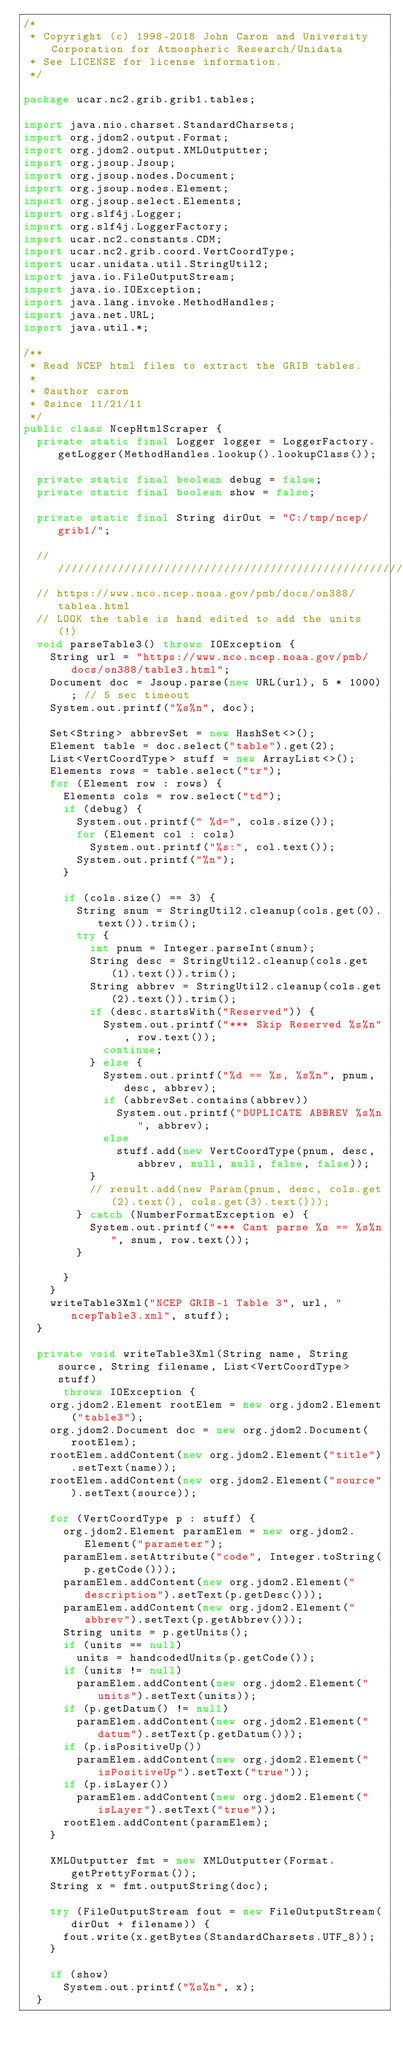<code> <loc_0><loc_0><loc_500><loc_500><_Java_>/*
 * Copyright (c) 1998-2018 John Caron and University Corporation for Atmospheric Research/Unidata
 * See LICENSE for license information.
 */

package ucar.nc2.grib.grib1.tables;

import java.nio.charset.StandardCharsets;
import org.jdom2.output.Format;
import org.jdom2.output.XMLOutputter;
import org.jsoup.Jsoup;
import org.jsoup.nodes.Document;
import org.jsoup.nodes.Element;
import org.jsoup.select.Elements;
import org.slf4j.Logger;
import org.slf4j.LoggerFactory;
import ucar.nc2.constants.CDM;
import ucar.nc2.grib.coord.VertCoordType;
import ucar.unidata.util.StringUtil2;
import java.io.FileOutputStream;
import java.io.IOException;
import java.lang.invoke.MethodHandles;
import java.net.URL;
import java.util.*;

/**
 * Read NCEP html files to extract the GRIB tables.
 *
 * @author caron
 * @since 11/21/11
 */
public class NcepHtmlScraper {
  private static final Logger logger = LoggerFactory.getLogger(MethodHandles.lookup().lookupClass());

  private static final boolean debug = false;
  private static final boolean show = false;

  private static final String dirOut = "C:/tmp/ncep/grib1/";

  //////////////////////////////////////////////////////////////////
  // https://www.nco.ncep.noaa.gov/pmb/docs/on388/tablea.html
  // LOOK the table is hand edited to add the units (!)
  void parseTable3() throws IOException {
    String url = "https://www.nco.ncep.noaa.gov/pmb/docs/on388/table3.html";
    Document doc = Jsoup.parse(new URL(url), 5 * 1000); // 5 sec timeout
    System.out.printf("%s%n", doc);

    Set<String> abbrevSet = new HashSet<>();
    Element table = doc.select("table").get(2);
    List<VertCoordType> stuff = new ArrayList<>();
    Elements rows = table.select("tr");
    for (Element row : rows) {
      Elements cols = row.select("td");
      if (debug) {
        System.out.printf(" %d=", cols.size());
        for (Element col : cols)
          System.out.printf("%s:", col.text());
        System.out.printf("%n");
      }

      if (cols.size() == 3) {
        String snum = StringUtil2.cleanup(cols.get(0).text()).trim();
        try {
          int pnum = Integer.parseInt(snum);
          String desc = StringUtil2.cleanup(cols.get(1).text()).trim();
          String abbrev = StringUtil2.cleanup(cols.get(2).text()).trim();
          if (desc.startsWith("Reserved")) {
            System.out.printf("*** Skip Reserved %s%n", row.text());
            continue;
          } else {
            System.out.printf("%d == %s, %s%n", pnum, desc, abbrev);
            if (abbrevSet.contains(abbrev))
              System.out.printf("DUPLICATE ABBREV %s%n", abbrev);
            else
              stuff.add(new VertCoordType(pnum, desc, abbrev, null, null, false, false));
          }
          // result.add(new Param(pnum, desc, cols.get(2).text(), cols.get(3).text()));
        } catch (NumberFormatException e) {
          System.out.printf("*** Cant parse %s == %s%n", snum, row.text());
        }

      }
    }
    writeTable3Xml("NCEP GRIB-1 Table 3", url, "ncepTable3.xml", stuff);
  }

  private void writeTable3Xml(String name, String source, String filename, List<VertCoordType> stuff)
      throws IOException {
    org.jdom2.Element rootElem = new org.jdom2.Element("table3");
    org.jdom2.Document doc = new org.jdom2.Document(rootElem);
    rootElem.addContent(new org.jdom2.Element("title").setText(name));
    rootElem.addContent(new org.jdom2.Element("source").setText(source));

    for (VertCoordType p : stuff) {
      org.jdom2.Element paramElem = new org.jdom2.Element("parameter");
      paramElem.setAttribute("code", Integer.toString(p.getCode()));
      paramElem.addContent(new org.jdom2.Element("description").setText(p.getDesc()));
      paramElem.addContent(new org.jdom2.Element("abbrev").setText(p.getAbbrev()));
      String units = p.getUnits();
      if (units == null)
        units = handcodedUnits(p.getCode());
      if (units != null)
        paramElem.addContent(new org.jdom2.Element("units").setText(units));
      if (p.getDatum() != null)
        paramElem.addContent(new org.jdom2.Element("datum").setText(p.getDatum()));
      if (p.isPositiveUp())
        paramElem.addContent(new org.jdom2.Element("isPositiveUp").setText("true"));
      if (p.isLayer())
        paramElem.addContent(new org.jdom2.Element("isLayer").setText("true"));
      rootElem.addContent(paramElem);
    }

    XMLOutputter fmt = new XMLOutputter(Format.getPrettyFormat());
    String x = fmt.outputString(doc);

    try (FileOutputStream fout = new FileOutputStream(dirOut + filename)) {
      fout.write(x.getBytes(StandardCharsets.UTF_8));
    }

    if (show)
      System.out.printf("%s%n", x);
  }
</code> 